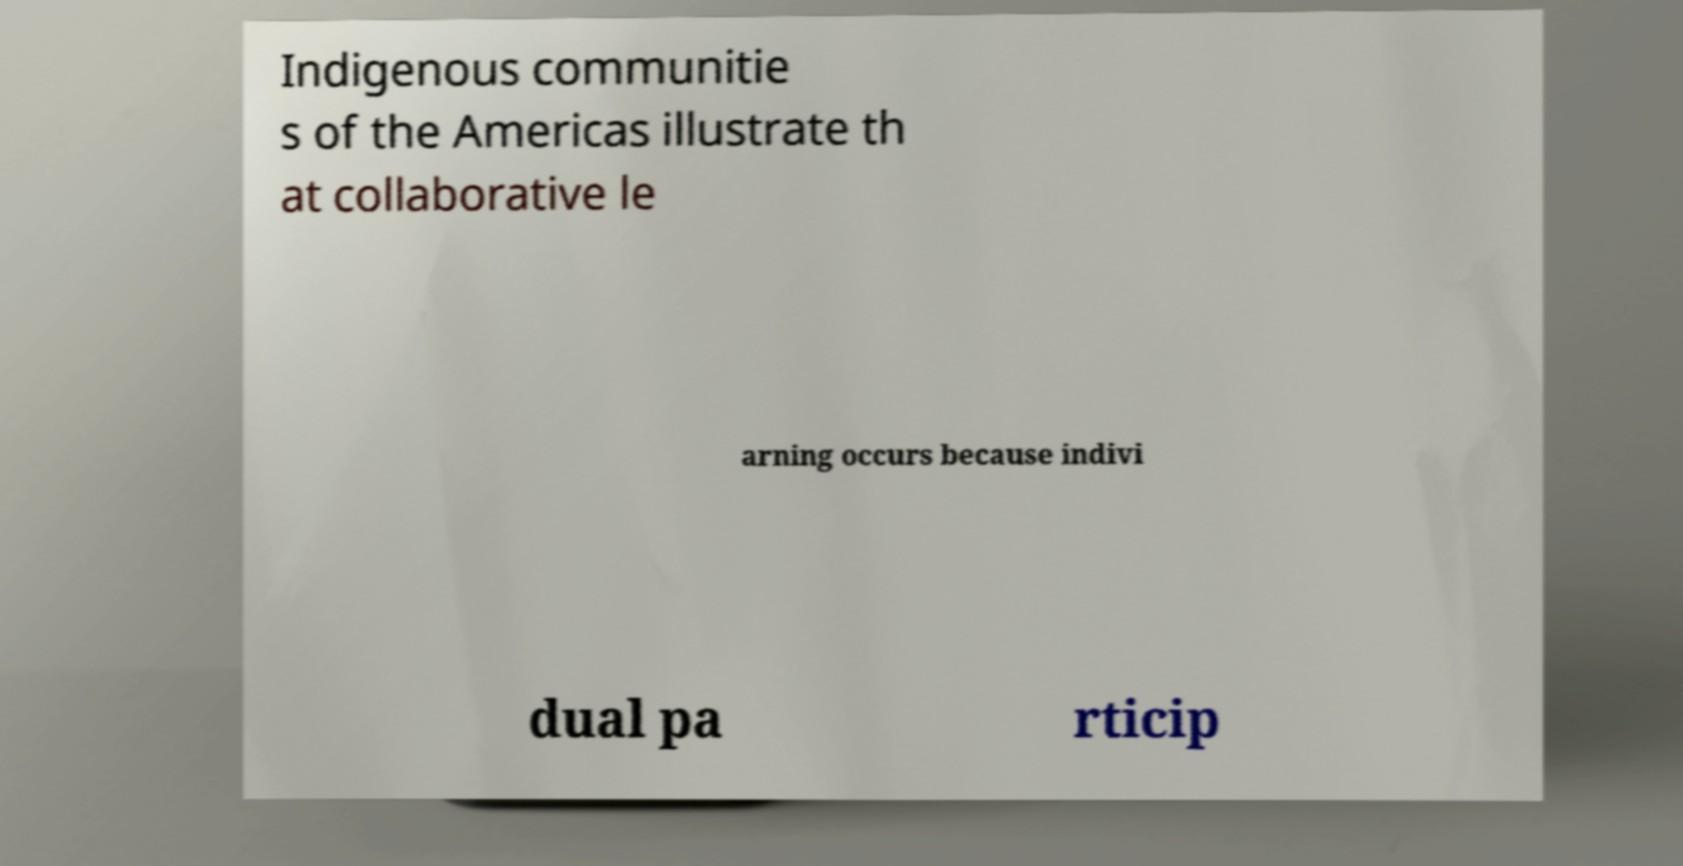Please identify and transcribe the text found in this image. Indigenous communitie s of the Americas illustrate th at collaborative le arning occurs because indivi dual pa rticip 